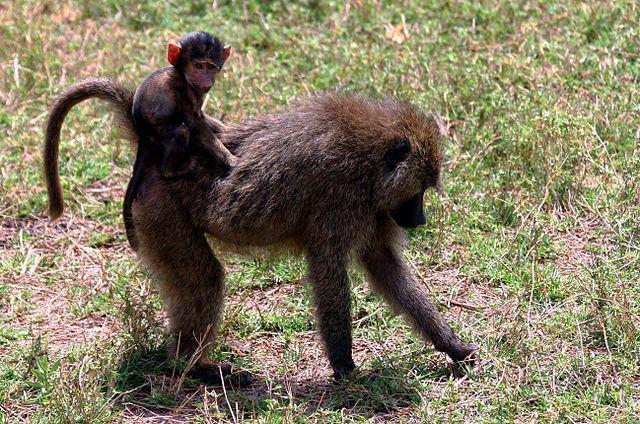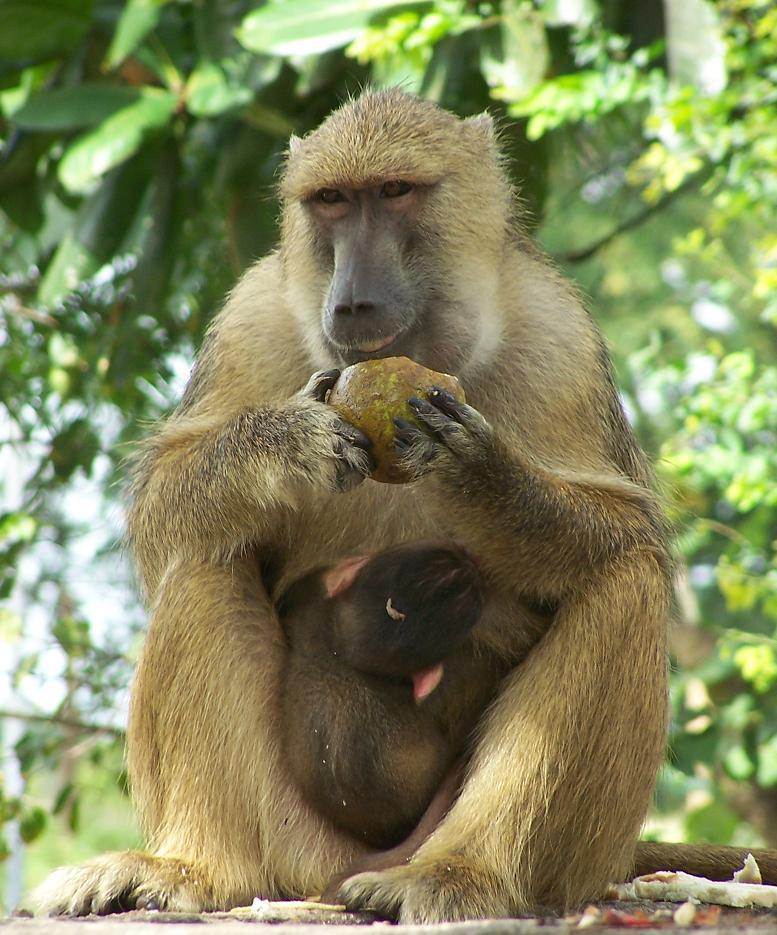The first image is the image on the left, the second image is the image on the right. For the images shown, is this caption "One image features a baby baboon next to an adult baboon" true? Answer yes or no. Yes. 